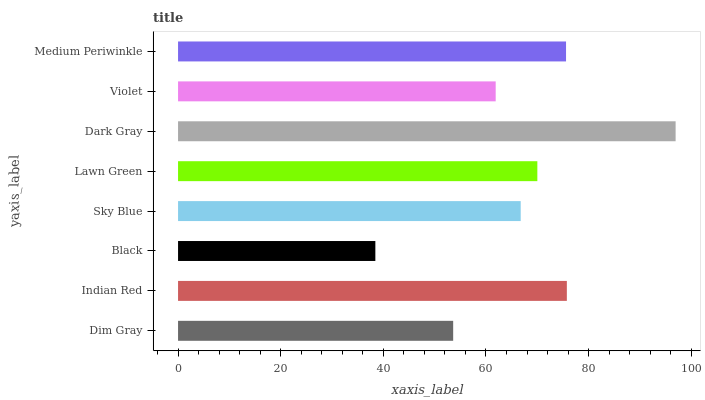Is Black the minimum?
Answer yes or no. Yes. Is Dark Gray the maximum?
Answer yes or no. Yes. Is Indian Red the minimum?
Answer yes or no. No. Is Indian Red the maximum?
Answer yes or no. No. Is Indian Red greater than Dim Gray?
Answer yes or no. Yes. Is Dim Gray less than Indian Red?
Answer yes or no. Yes. Is Dim Gray greater than Indian Red?
Answer yes or no. No. Is Indian Red less than Dim Gray?
Answer yes or no. No. Is Lawn Green the high median?
Answer yes or no. Yes. Is Sky Blue the low median?
Answer yes or no. Yes. Is Dim Gray the high median?
Answer yes or no. No. Is Black the low median?
Answer yes or no. No. 